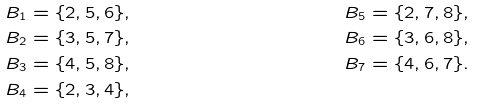<formula> <loc_0><loc_0><loc_500><loc_500>B _ { 1 } & = \{ 2 , 5 , 6 \} , & B _ { 5 } & = \{ 2 , 7 , 8 \} , \\ B _ { 2 } & = \{ 3 , 5 , 7 \} , & B _ { 6 } & = \{ 3 , 6 , 8 \} , \\ B _ { 3 } & = \{ 4 , 5 , 8 \} , & B _ { 7 } & = \{ 4 , 6 , 7 \} . \\ B _ { 4 } & = \{ 2 , 3 , 4 \} , & &</formula> 